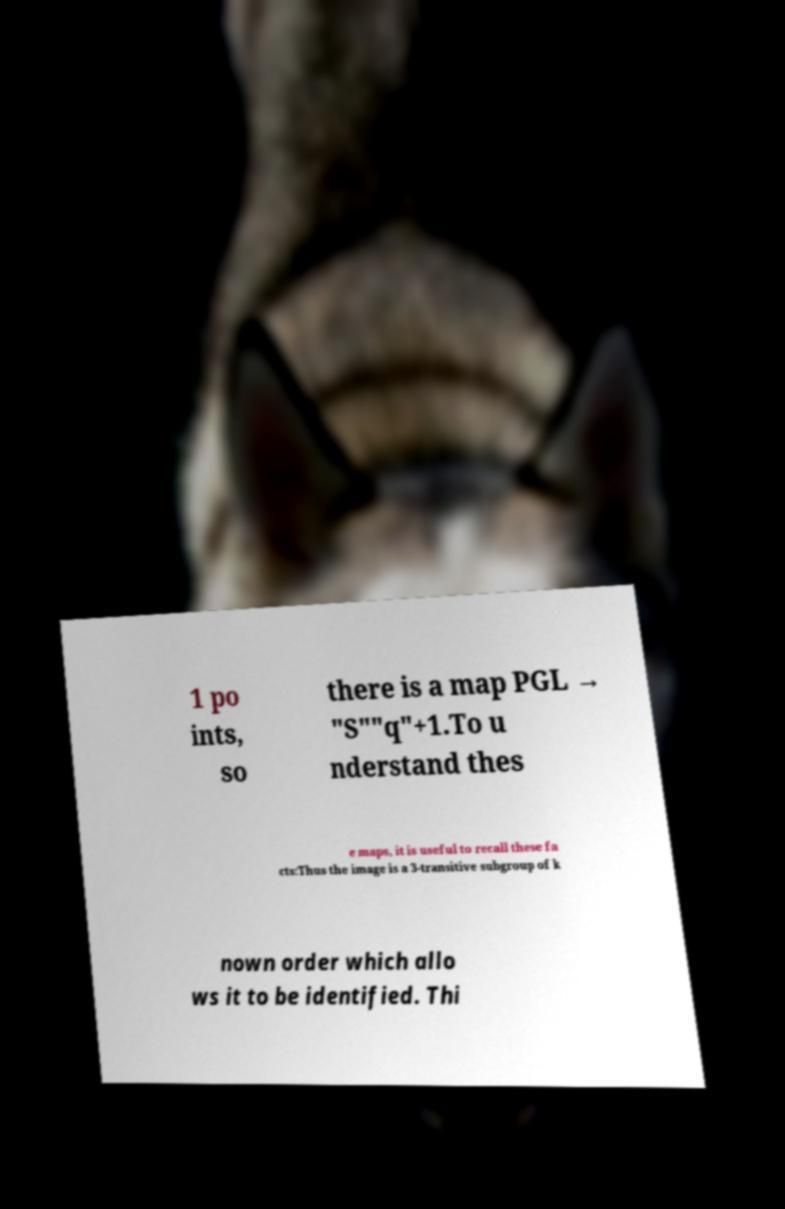Could you extract and type out the text from this image? 1 po ints, so there is a map PGL → "S""q"+1.To u nderstand thes e maps, it is useful to recall these fa cts:Thus the image is a 3-transitive subgroup of k nown order which allo ws it to be identified. Thi 